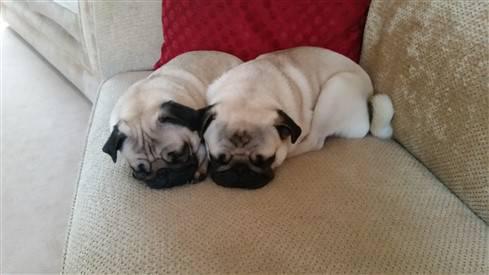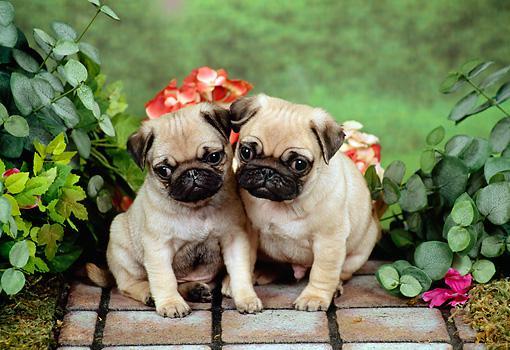The first image is the image on the left, the second image is the image on the right. Evaluate the accuracy of this statement regarding the images: "One pair of dogs is sitting in front of some flowers.". Is it true? Answer yes or no. Yes. The first image is the image on the left, the second image is the image on the right. For the images shown, is this caption "Two nearly identical looking pug puppies lie flat on their bellies, side-by-side, with eyes closed." true? Answer yes or no. Yes. 